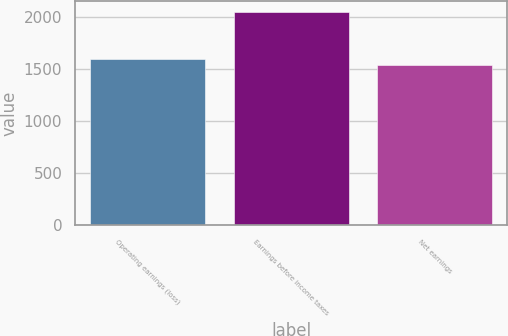<chart> <loc_0><loc_0><loc_500><loc_500><bar_chart><fcel>Operating earnings (loss)<fcel>Earnings before income taxes<fcel>Net earnings<nl><fcel>1592.54<fcel>2051.9<fcel>1541.5<nl></chart> 